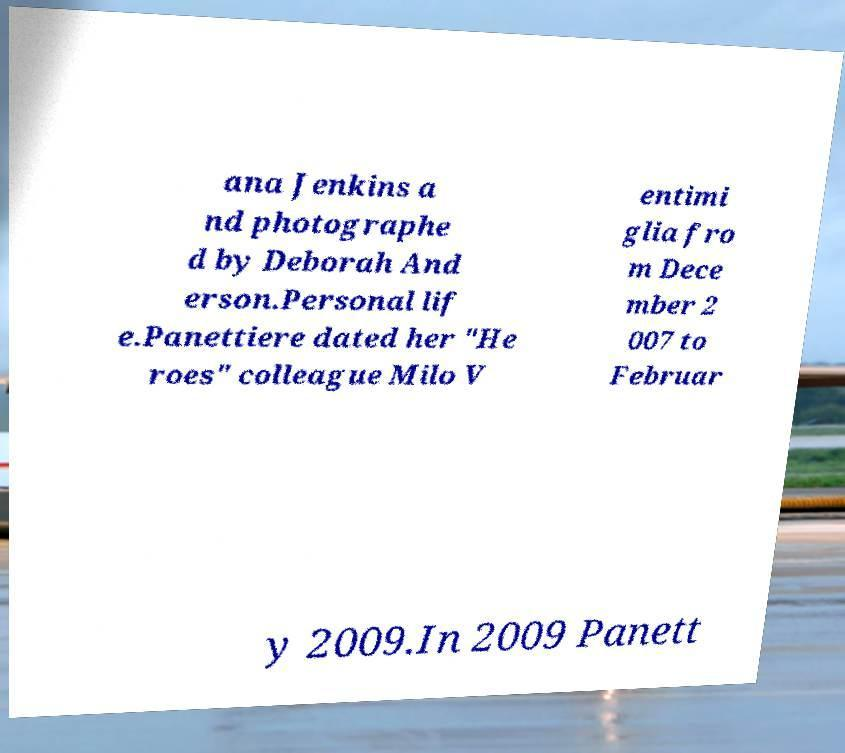Could you extract and type out the text from this image? ana Jenkins a nd photographe d by Deborah And erson.Personal lif e.Panettiere dated her "He roes" colleague Milo V entimi glia fro m Dece mber 2 007 to Februar y 2009.In 2009 Panett 